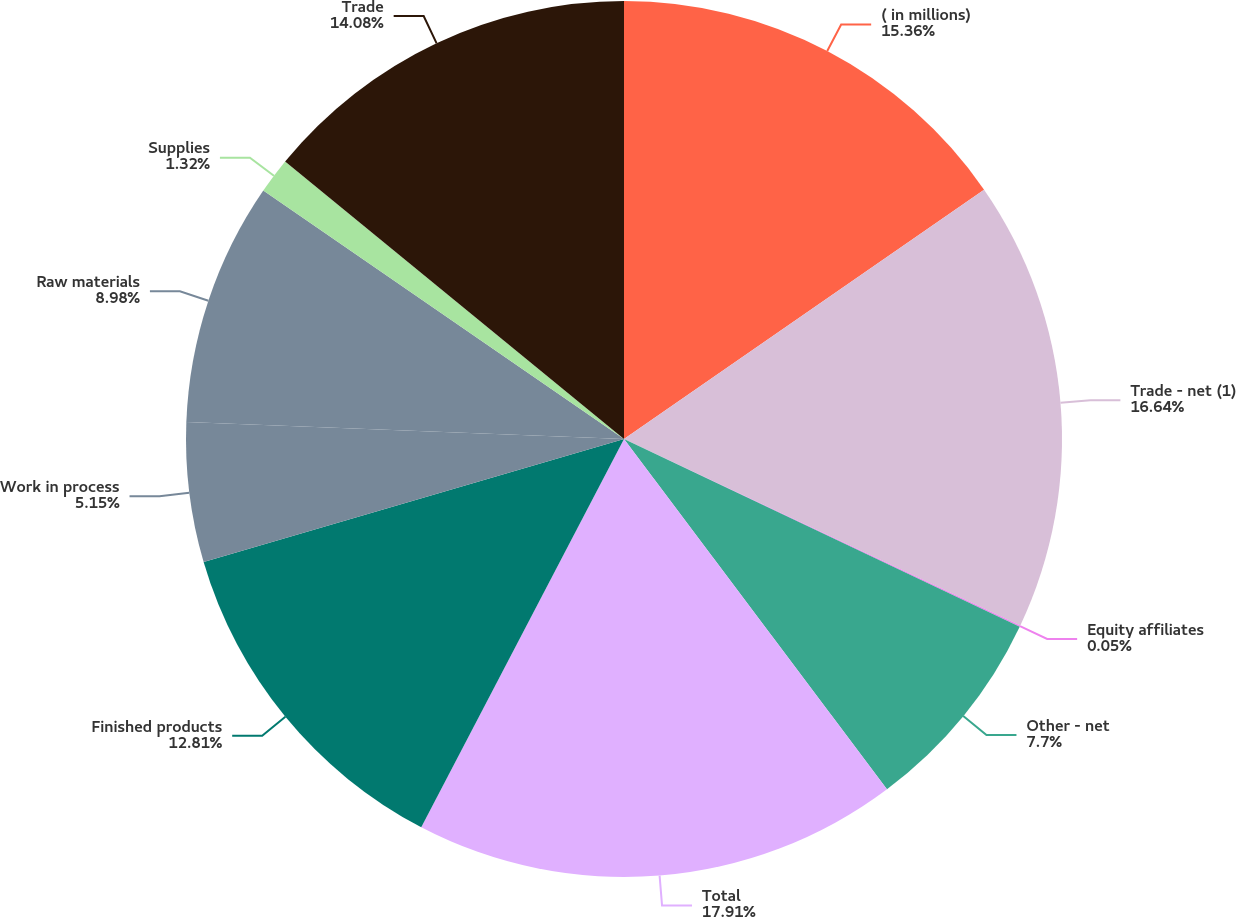Convert chart. <chart><loc_0><loc_0><loc_500><loc_500><pie_chart><fcel>( in millions)<fcel>Trade - net (1)<fcel>Equity affiliates<fcel>Other - net<fcel>Total<fcel>Finished products<fcel>Work in process<fcel>Raw materials<fcel>Supplies<fcel>Trade<nl><fcel>15.36%<fcel>16.64%<fcel>0.05%<fcel>7.7%<fcel>17.91%<fcel>12.81%<fcel>5.15%<fcel>8.98%<fcel>1.32%<fcel>14.08%<nl></chart> 